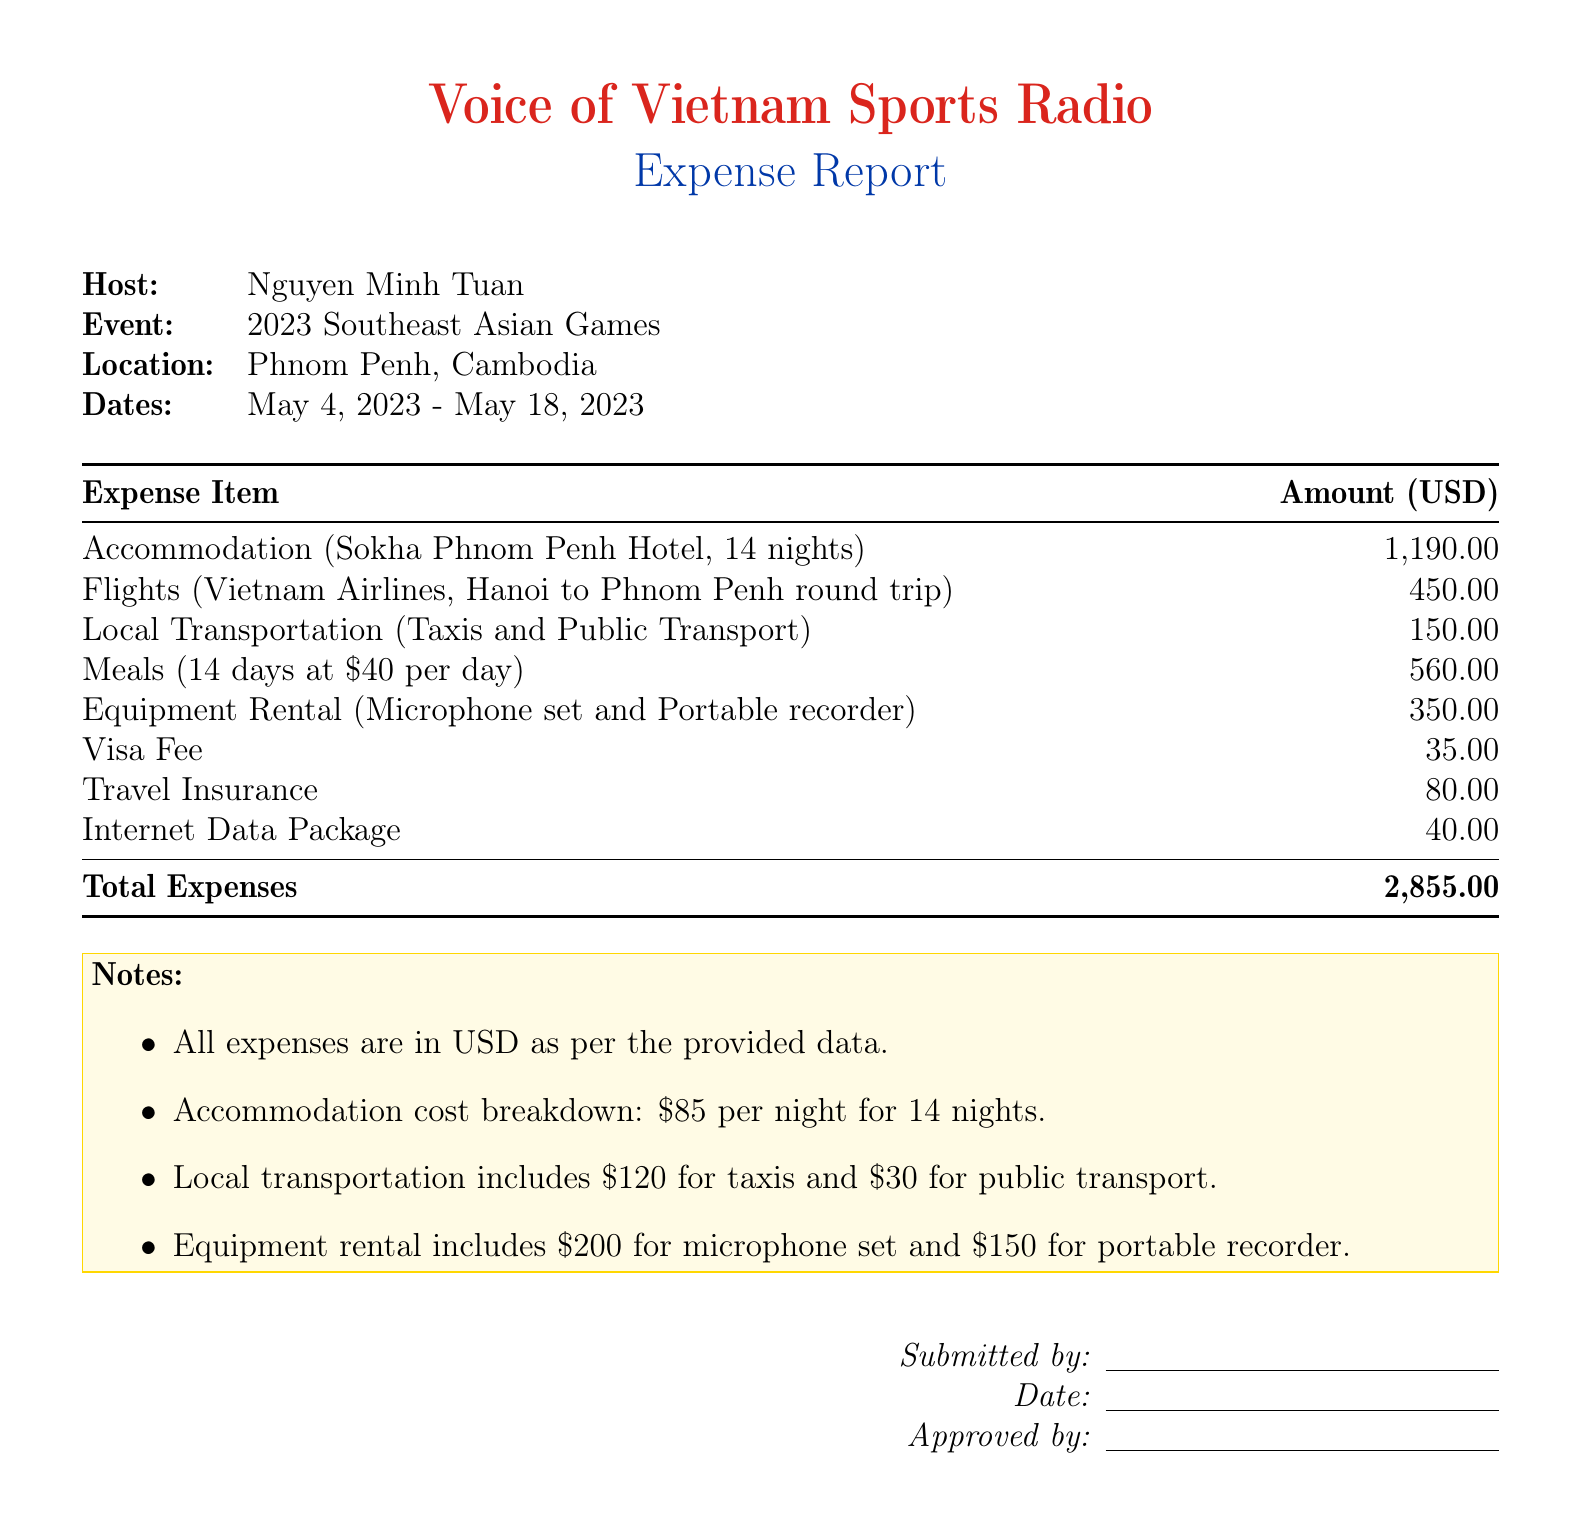What is the event? The document specifies that the expense report is for the 2023 Southeast Asian Games.
Answer: 2023 Southeast Asian Games What is the total amount of expenses? The total expenses are summarized at the bottom of the expense report, totaling 2,855.00 USD.
Answer: 2,855.00 Who is the host of the report? The document clearly indicates the host's name at the top.
Answer: Nguyen Minh Tuan What is the accommodation cost per night? The note clarifies that the accommodation cost is 85 USD per night for 14 nights.
Answer: 85 When was the event held? The dates for the event are provided in the document, spanning from May 4, 2023 to May 18, 2023.
Answer: May 4, 2023 - May 18, 2023 What is the cost of the visa fee? The visa fee is listed as a single expense in the expense report.
Answer: 35.00 How many nights was the accommodation booked? The accommodation section indicates the duration of the stay in nights.
Answer: 14 What is the local transportation cost breakdown? The notes specify the breakdown of local transportation costs as 120 for taxis and 30 for public transport.
Answer: 120 for taxis and 30 for public transport What equipment was rented? The document lists the types of equipment rented as part of the travel expenses.
Answer: Microphone set and Portable recorder 